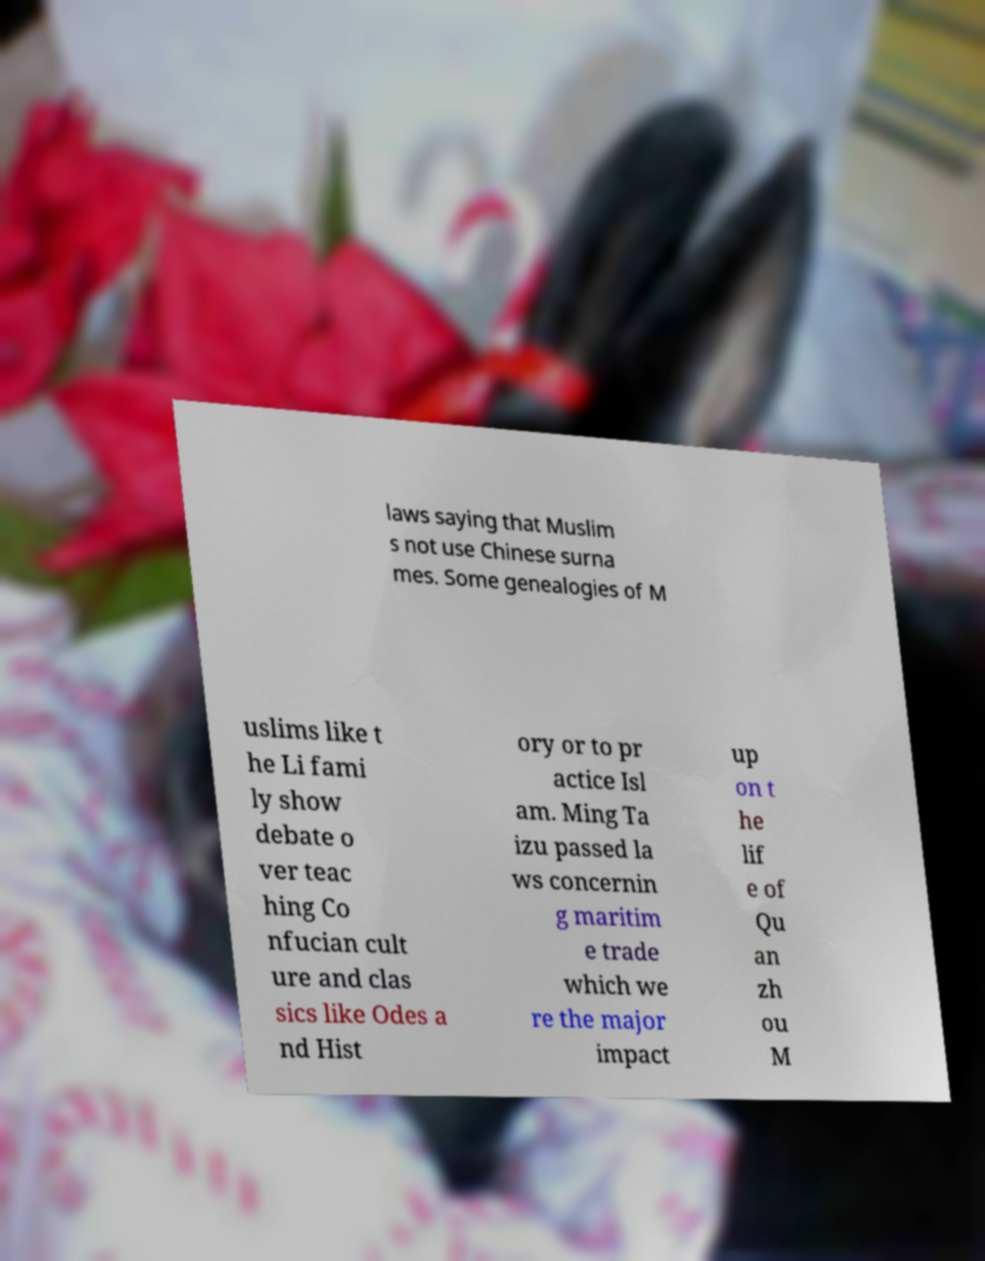Please identify and transcribe the text found in this image. laws saying that Muslim s not use Chinese surna mes. Some genealogies of M uslims like t he Li fami ly show debate o ver teac hing Co nfucian cult ure and clas sics like Odes a nd Hist ory or to pr actice Isl am. Ming Ta izu passed la ws concernin g maritim e trade which we re the major impact up on t he lif e of Qu an zh ou M 